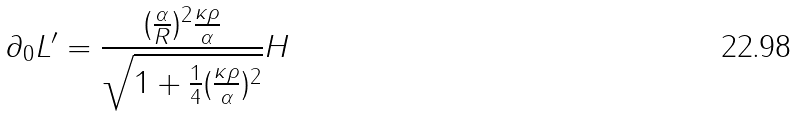Convert formula to latex. <formula><loc_0><loc_0><loc_500><loc_500>\partial _ { 0 } L ^ { \prime } = \frac { ( \frac { \alpha } { R } ) ^ { 2 } \frac { \kappa \rho } { \alpha } } { \sqrt { 1 + \frac { 1 } { 4 } ( \frac { \kappa \rho } { \alpha } ) ^ { 2 } } } H</formula> 